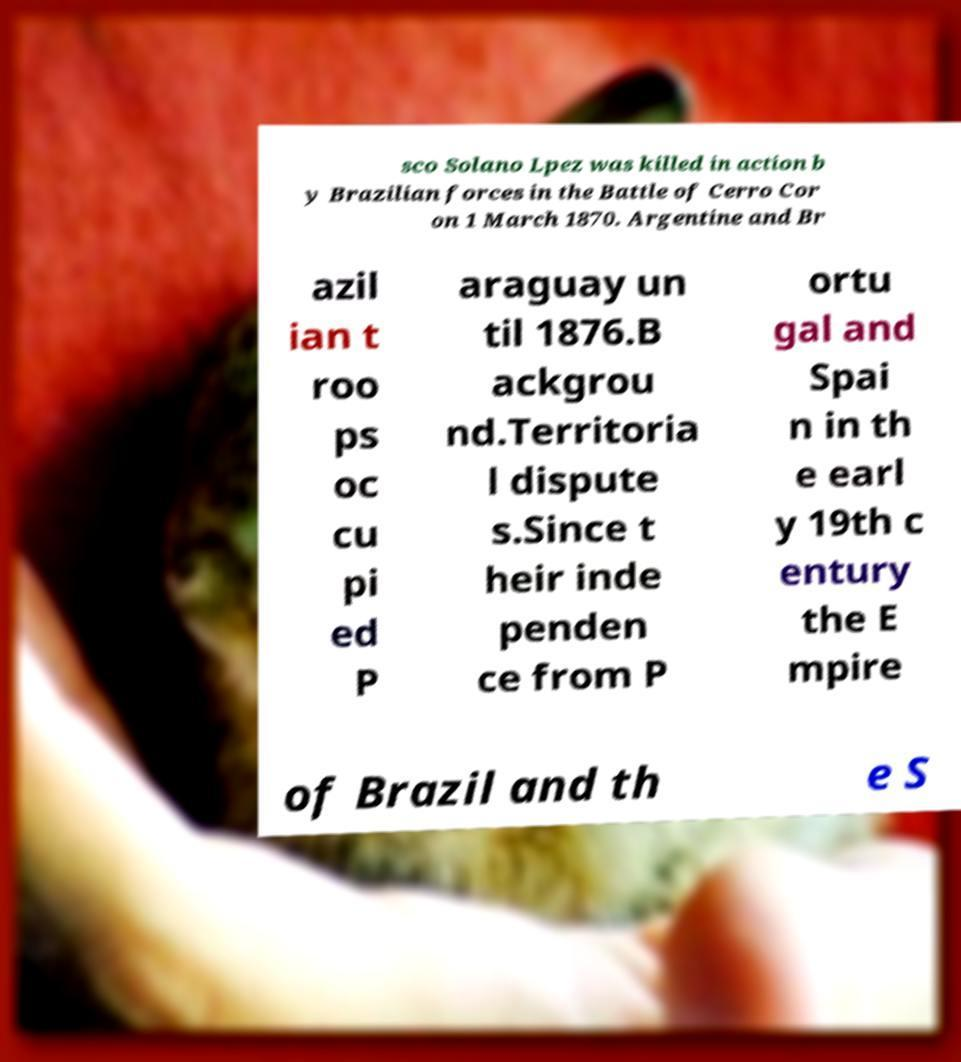What messages or text are displayed in this image? I need them in a readable, typed format. sco Solano Lpez was killed in action b y Brazilian forces in the Battle of Cerro Cor on 1 March 1870. Argentine and Br azil ian t roo ps oc cu pi ed P araguay un til 1876.B ackgrou nd.Territoria l dispute s.Since t heir inde penden ce from P ortu gal and Spai n in th e earl y 19th c entury the E mpire of Brazil and th e S 